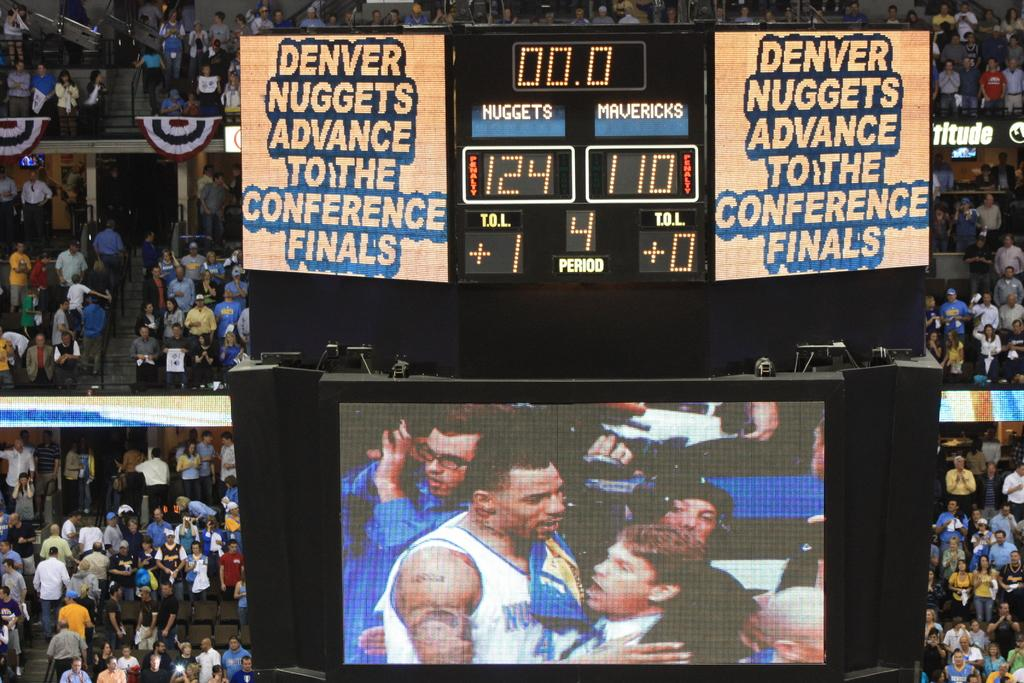<image>
Offer a succinct explanation of the picture presented. The Denver Nuggets have just advanced to the conference finals, according to the Jumbotron. 